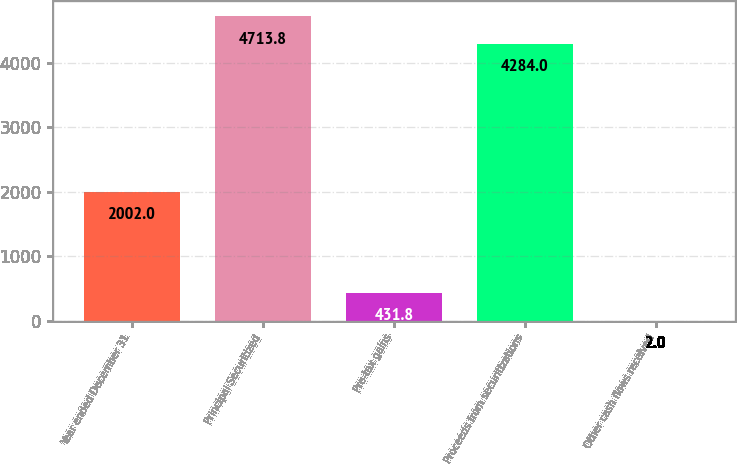Convert chart. <chart><loc_0><loc_0><loc_500><loc_500><bar_chart><fcel>Year ended December 31<fcel>Principal Securitized<fcel>Pre-tax gains<fcel>Proceeds from securitizations<fcel>Other cash flows received<nl><fcel>2002<fcel>4713.8<fcel>431.8<fcel>4284<fcel>2<nl></chart> 